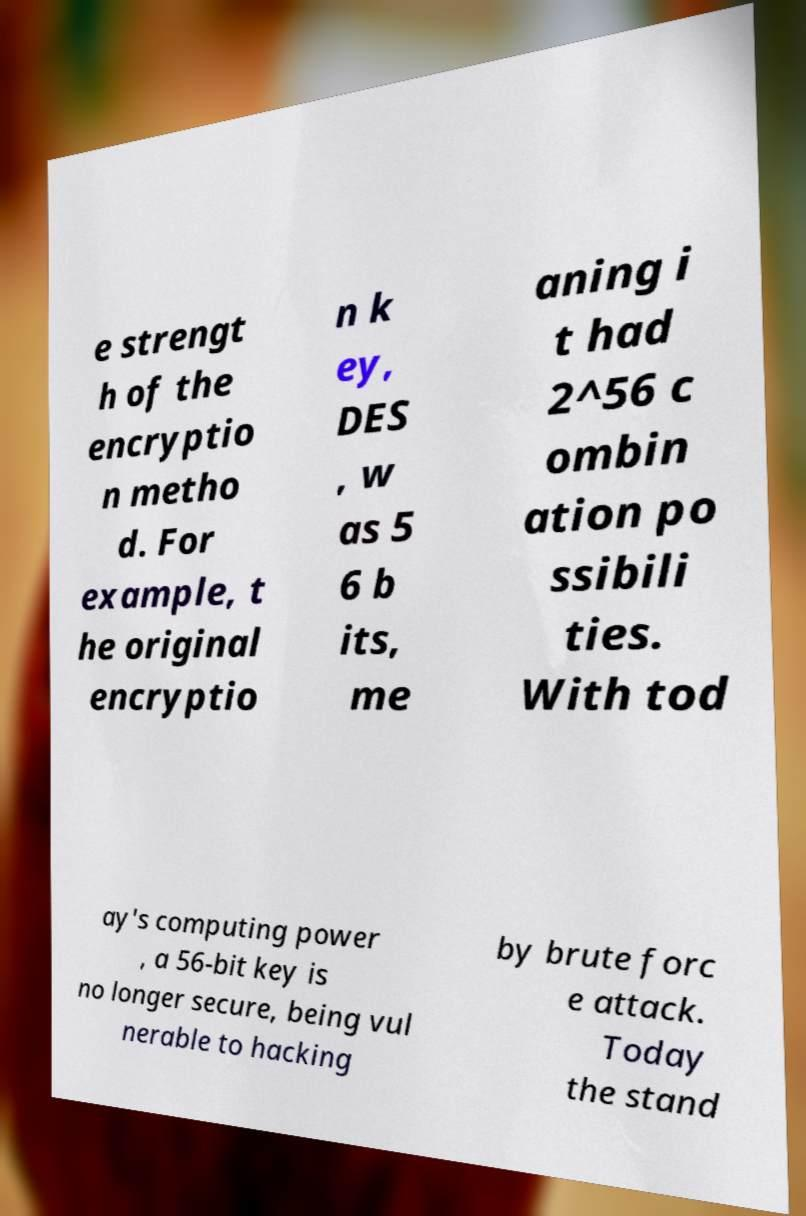I need the written content from this picture converted into text. Can you do that? e strengt h of the encryptio n metho d. For example, t he original encryptio n k ey, DES , w as 5 6 b its, me aning i t had 2^56 c ombin ation po ssibili ties. With tod ay's computing power , a 56-bit key is no longer secure, being vul nerable to hacking by brute forc e attack. Today the stand 